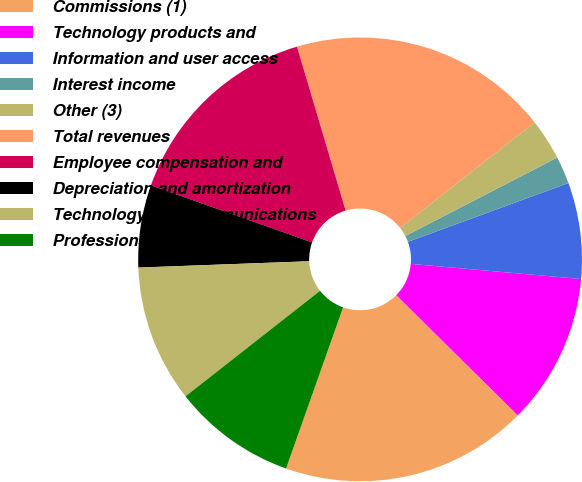<chart> <loc_0><loc_0><loc_500><loc_500><pie_chart><fcel>Commissions (1)<fcel>Technology products and<fcel>Information and user access<fcel>Interest income<fcel>Other (3)<fcel>Total revenues<fcel>Employee compensation and<fcel>Depreciation and amortization<fcel>Technology and communications<fcel>Professional and consulting<nl><fcel>18.0%<fcel>11.0%<fcel>7.0%<fcel>2.0%<fcel>3.0%<fcel>19.0%<fcel>15.0%<fcel>6.0%<fcel>10.0%<fcel>9.0%<nl></chart> 